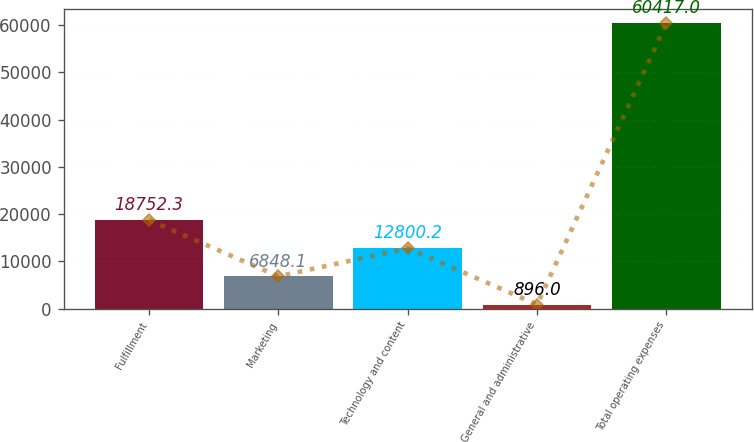Convert chart to OTSL. <chart><loc_0><loc_0><loc_500><loc_500><bar_chart><fcel>Fulfillment<fcel>Marketing<fcel>Technology and content<fcel>General and administrative<fcel>Total operating expenses<nl><fcel>18752.3<fcel>6848.1<fcel>12800.2<fcel>896<fcel>60417<nl></chart> 